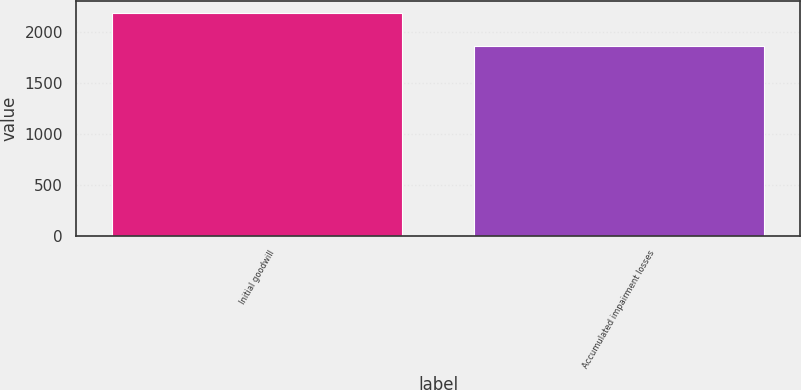<chart> <loc_0><loc_0><loc_500><loc_500><bar_chart><fcel>Initial goodwill<fcel>Accumulated impairment losses<nl><fcel>2194<fcel>1871<nl></chart> 